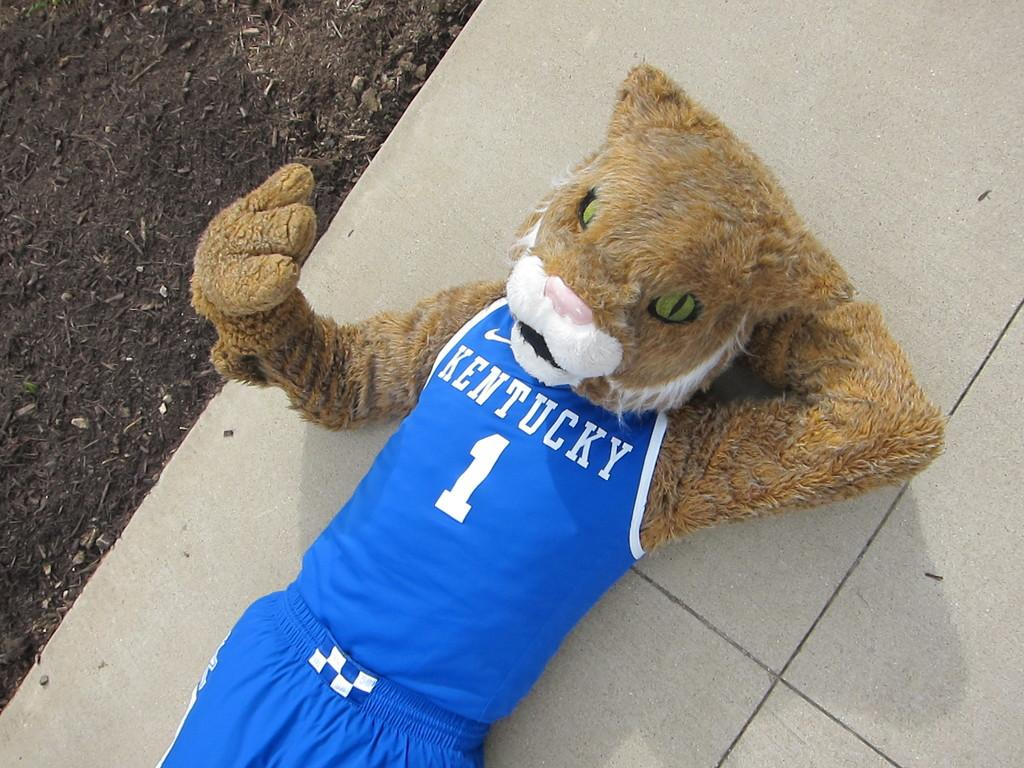What type of object can be seen in the image? There is a toy in the image. What is the toy wearing or holding? The toy is not wearing or holding anything mentioned in the provided facts. What type of clothing item is present in the image? There is a T-shirt with text printed on it in the image. What is the text on the T-shirt? The provided facts do not mention the text on the T-shirt. Can you describe the feeling of the seashore in the image? There is no mention of a seashore in the provided facts, so it cannot be described in the image. What type of basin is visible in the image? There is no basin mentioned in the provided facts, so it cannot be described in the image. 